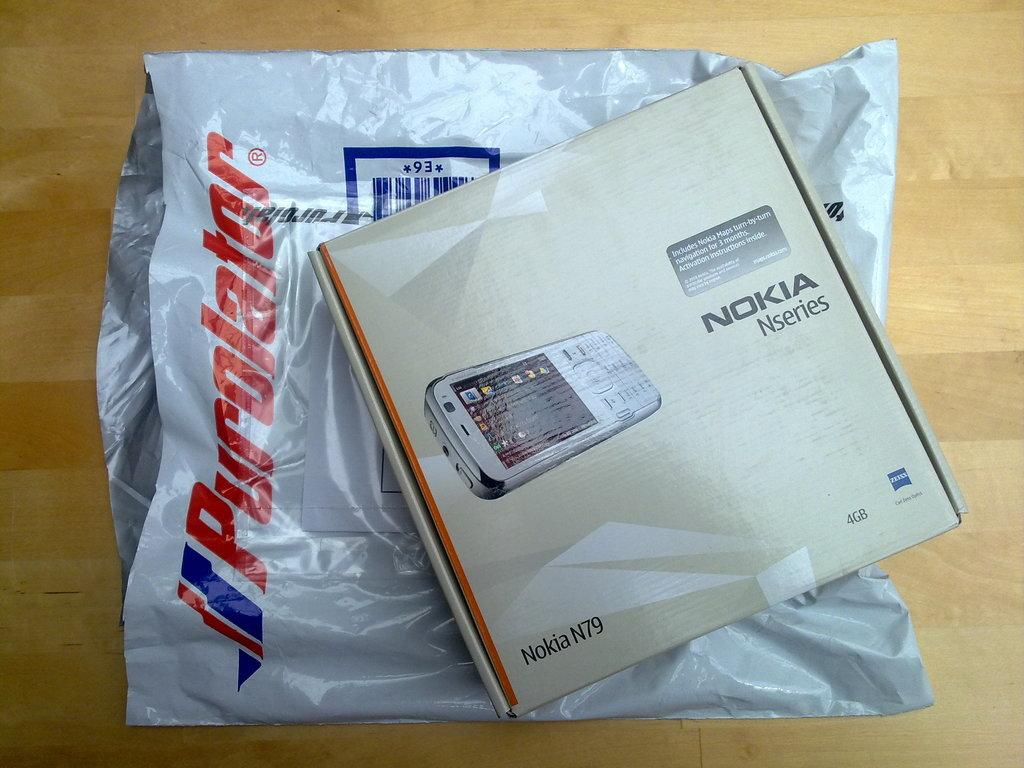Provide a one-sentence caption for the provided image. The product that was in the bag is a Nokia electronic device. 